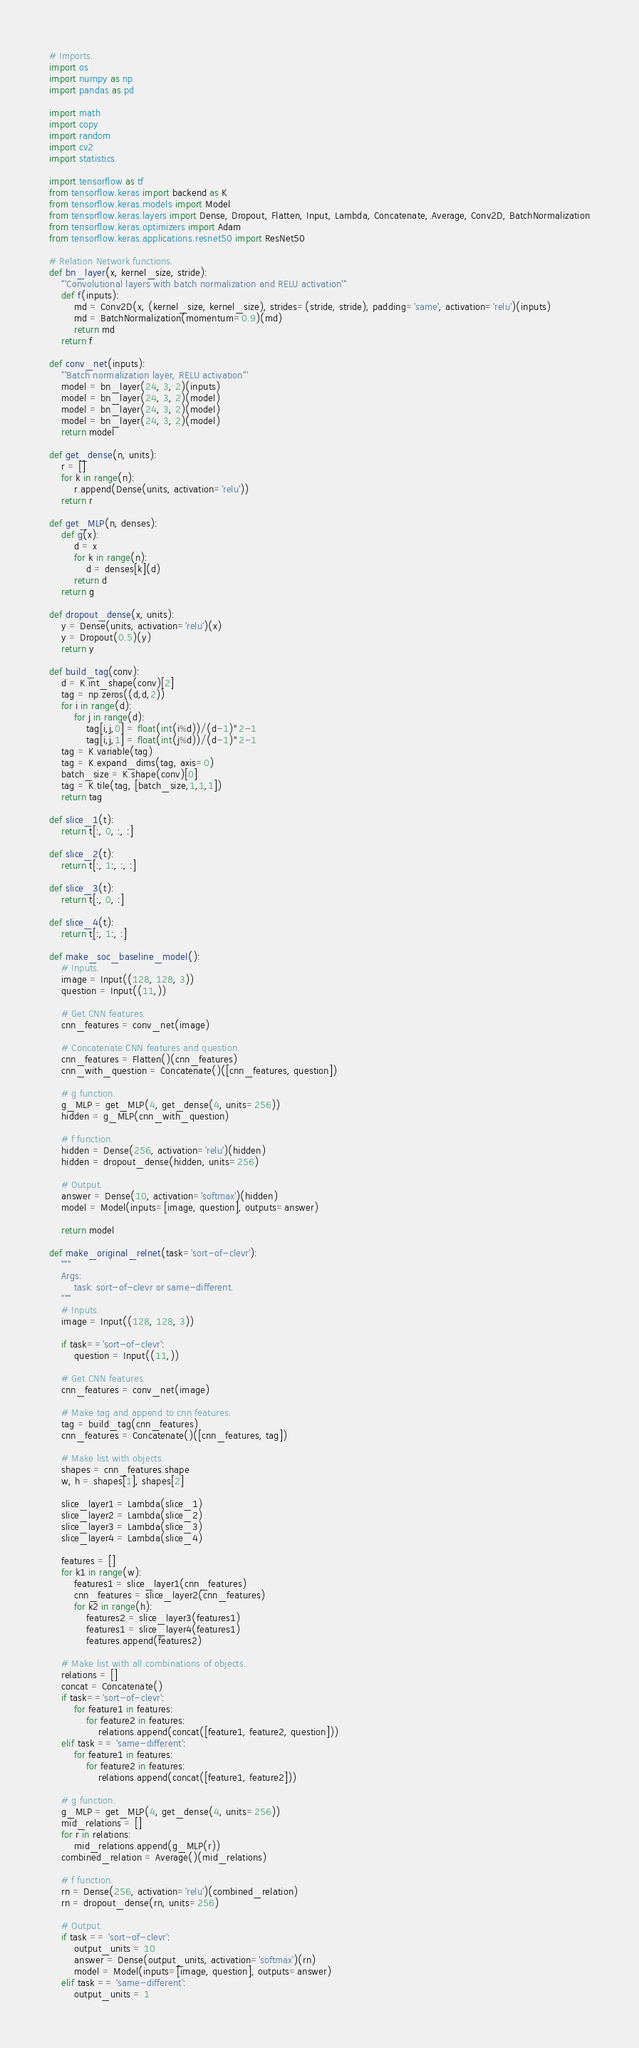<code> <loc_0><loc_0><loc_500><loc_500><_Python_># Imports.
import os
import numpy as np
import pandas as pd

import math
import copy
import random
import cv2
import statistics

import tensorflow as tf
from tensorflow.keras import backend as K
from tensorflow.keras.models import Model
from tensorflow.keras.layers import Dense, Dropout, Flatten, Input, Lambda, Concatenate, Average, Conv2D, BatchNormalization
from tensorflow.keras.optimizers import Adam
from tensorflow.keras.applications.resnet50 import ResNet50

# Relation Network functions.
def bn_layer(x, kernel_size, stride):
    '''Convolutional layers with batch normalization and RELU activation'''
    def f(inputs):
        md = Conv2D(x, (kernel_size, kernel_size), strides=(stride, stride), padding='same', activation='relu')(inputs)
        md = BatchNormalization(momentum=0.9)(md)
        return md
    return f

def conv_net(inputs):
    '''Batch normalization layer, RELU activation'''
    model = bn_layer(24, 3, 2)(inputs)
    model = bn_layer(24, 3, 2)(model)
    model = bn_layer(24, 3, 2)(model)
    model = bn_layer(24, 3, 2)(model)
    return model

def get_dense(n, units):
    r = []
    for k in range(n):
        r.append(Dense(units, activation='relu'))
    return r

def get_MLP(n, denses):
    def g(x):
        d = x
        for k in range(n):
            d = denses[k](d)
        return d
    return g

def dropout_dense(x, units):
    y = Dense(units, activation='relu')(x)
    y = Dropout(0.5)(y)
    return y

def build_tag(conv):
    d = K.int_shape(conv)[2]
    tag = np.zeros((d,d,2))
    for i in range(d):
        for j in range(d):
            tag[i,j,0] = float(int(i%d))/(d-1)*2-1
            tag[i,j,1] = float(int(j%d))/(d-1)*2-1
    tag = K.variable(tag)
    tag = K.expand_dims(tag, axis=0)
    batch_size = K.shape(conv)[0]
    tag = K.tile(tag, [batch_size,1,1,1])
    return tag

def slice_1(t):
    return t[:, 0, :, :]

def slice_2(t):
    return t[:, 1:, :, :]

def slice_3(t):
    return t[:, 0, :]

def slice_4(t):
    return t[:, 1:, :]

def make_soc_baseline_model():
    # Inputs.
    image = Input((128, 128, 3))
    question = Input((11,))
    
    # Get CNN features.
    cnn_features = conv_net(image)
    
    # Concatenate CNN features and question.
    cnn_features = Flatten()(cnn_features)
    cnn_with_question = Concatenate()([cnn_features, question])
    
    # g function.
    g_MLP = get_MLP(4, get_dense(4, units=256))
    hidden = g_MLP(cnn_with_question)
    
    # f function.
    hidden = Dense(256, activation='relu')(hidden)
    hidden = dropout_dense(hidden, units=256)
    
    # Output.
    answer = Dense(10, activation='softmax')(hidden)
    model = Model(inputs=[image, question], outputs=answer)
    
    return model

def make_original_relnet(task='sort-of-clevr'):
    """
    Args:
        task: sort-of-clevr or same-different.
    """
    # Inputs.
    image = Input((128, 128, 3))
    
    if task=='sort-of-clevr':
        question = Input((11,))

    # Get CNN features.
    cnn_features = conv_net(image)

    # Make tag and append to cnn features.
    tag = build_tag(cnn_features)
    cnn_features = Concatenate()([cnn_features, tag])

    # Make list with objects.
    shapes = cnn_features.shape
    w, h = shapes[1], shapes[2]
            
    slice_layer1 = Lambda(slice_1)
    slice_layer2 = Lambda(slice_2)
    slice_layer3 = Lambda(slice_3)
    slice_layer4 = Lambda(slice_4)

    features = []
    for k1 in range(w):
        features1 = slice_layer1(cnn_features)
        cnn_features = slice_layer2(cnn_features)
        for k2 in range(h):
            features2 = slice_layer3(features1)
            features1 = slice_layer4(features1)
            features.append(features2)
        
    # Make list with all combinations of objects.
    relations = []
    concat = Concatenate()
    if task=='sort-of-clevr':
        for feature1 in features:
            for feature2 in features:
                relations.append(concat([feature1, feature2, question]))
    elif task == 'same-different':
        for feature1 in features:
            for feature2 in features:
                relations.append(concat([feature1, feature2]))

    # g function.
    g_MLP = get_MLP(4, get_dense(4, units=256))
    mid_relations = []
    for r in relations:
        mid_relations.append(g_MLP(r))
    combined_relation = Average()(mid_relations)

    # f function.
    rn = Dense(256, activation='relu')(combined_relation)
    rn = dropout_dense(rn, units=256)
    
    # Output.
    if task == 'sort-of-clevr':
        output_units = 10
        answer = Dense(output_units, activation='softmax')(rn)
        model = Model(inputs=[image, question], outputs=answer)
    elif task == 'same-different':
        output_units = 1</code> 